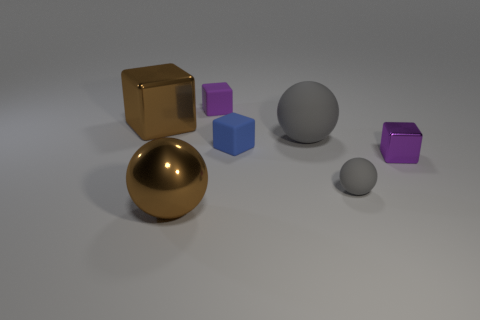What materials do the objects in the image seem to be made of? The various objects in the image appear to be made of different materials. The shiny gold and gray spheres seem to be metallic, while the cubes are possibly made of a matte plastic, suggesting a contrast in material properties. 